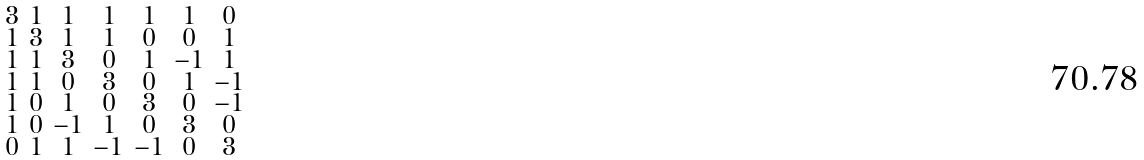<formula> <loc_0><loc_0><loc_500><loc_500>\begin{smallmatrix} 3 & 1 & 1 & 1 & 1 & 1 & 0 \\ 1 & 3 & 1 & 1 & 0 & 0 & 1 \\ 1 & 1 & 3 & 0 & 1 & - 1 & 1 \\ 1 & 1 & 0 & 3 & 0 & 1 & - 1 \\ 1 & 0 & 1 & 0 & 3 & 0 & - 1 \\ 1 & 0 & - 1 & 1 & 0 & 3 & 0 \\ 0 & 1 & 1 & - 1 & - 1 & 0 & 3 \end{smallmatrix}</formula> 